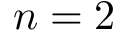Convert formula to latex. <formula><loc_0><loc_0><loc_500><loc_500>n = 2</formula> 